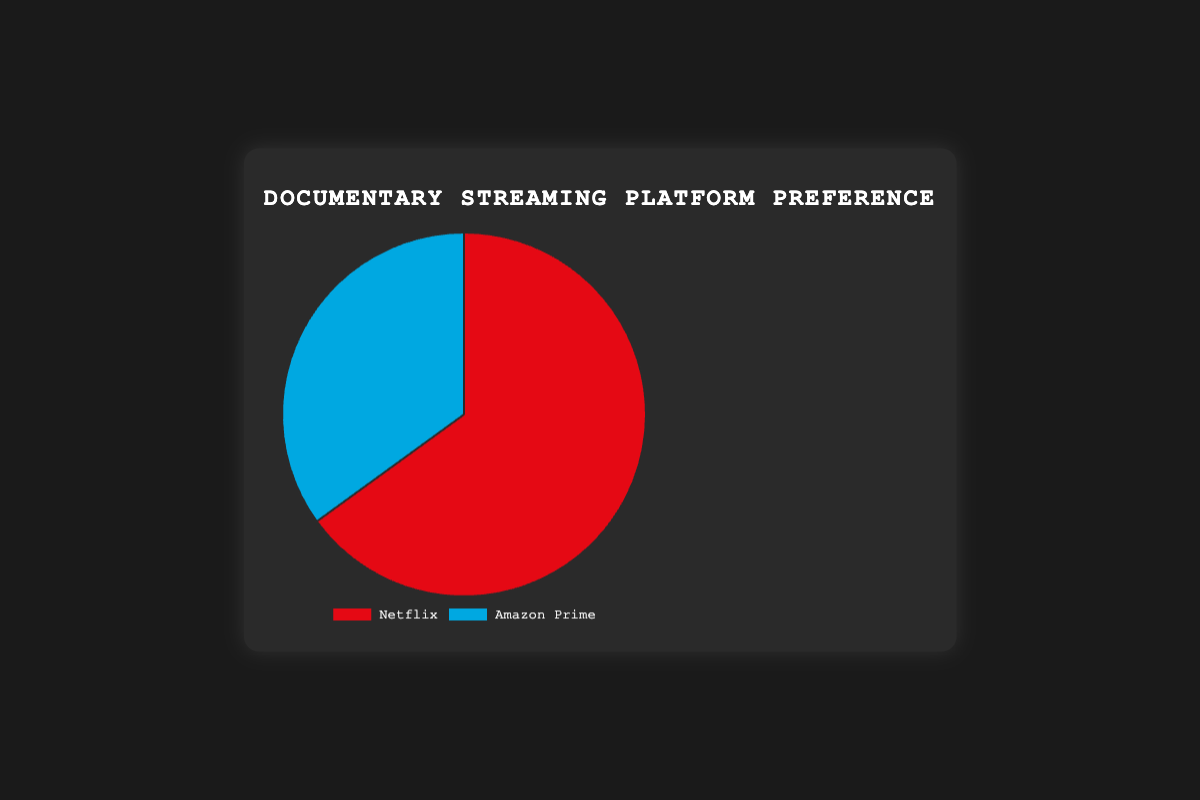What's the percentage preference for Netflix? The pie chart indicates that 65% of people prefer Netflix for watching documentaries.
Answer: 65% What's the percentage difference between Netflix and Amazon Prime preference? Netflix has 65% preference while Amazon Prime has 35%. The difference is 65% - 35% = 30%.
Answer: 30% Which platform has more preference for documentaries? The pie chart shows Netflix has 65% preference, which is higher compared to Amazon Prime with 35%.
Answer: Netflix By how many percentage points does Netflix's preference exceed Amazon Prime's preference? Netflix's preference is 65% and Amazon Prime's is 35%. The difference in preference is 65% - 35% = 30 percentage points.
Answer: 30 percentage points What proportion of people prefer Amazon Prime? The pie chart indicates that 35% of people prefer Amazon Prime for watching documentaries.
Answer: 35% If the data represented 100 people, how many would prefer Netflix and how many would prefer Amazon Prime? If 65% prefer Netflix and 35% prefer Amazon Prime, in a sample of 100 people, 65 would prefer Netflix and 35 would prefer Amazon Prime.
Answer: 65 prefer Netflix, 35 prefer Amazon Prime What is the color that represents Amazon Prime's preference? The pie chart uses a blue shade to represent Amazon Prime's preference.
Answer: Blue What is the combined preference percentage for both platforms? The preference percentages for Netflix and Amazon Prime add up to 65% + 35% = 100%.
Answer: 100% If 200 people were surveyed, how many more people would prefer Netflix over Amazon Prime? In a sample of 200 people, 65% would amount to 130 people for Netflix, and 35% would amount to 70 people for Amazon Prime. The difference is 130 - 70 = 60 people.
Answer: 60 people 